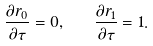<formula> <loc_0><loc_0><loc_500><loc_500>\frac { \partial r _ { 0 } } { \partial \tau } = 0 , \quad \frac { \partial r _ { 1 } } { \partial \tau } = 1 .</formula> 